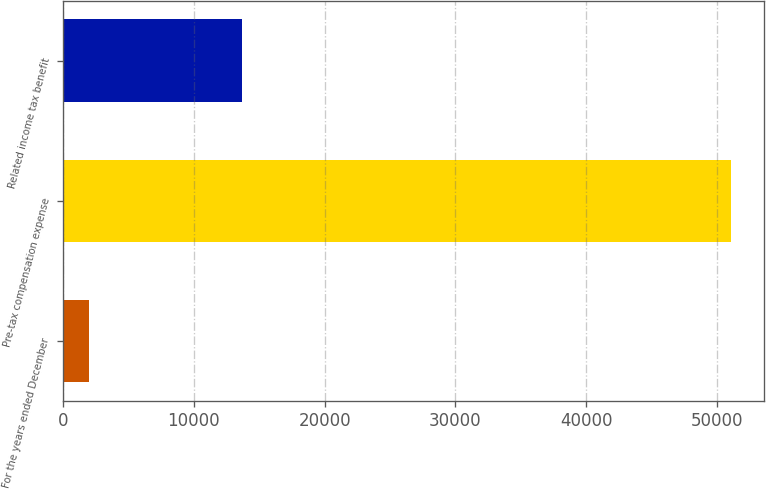<chart> <loc_0><loc_0><loc_500><loc_500><bar_chart><fcel>For the years ended December<fcel>Pre-tax compensation expense<fcel>Related income tax benefit<nl><fcel>2017<fcel>51061<fcel>13684<nl></chart> 